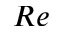Convert formula to latex. <formula><loc_0><loc_0><loc_500><loc_500>R e</formula> 